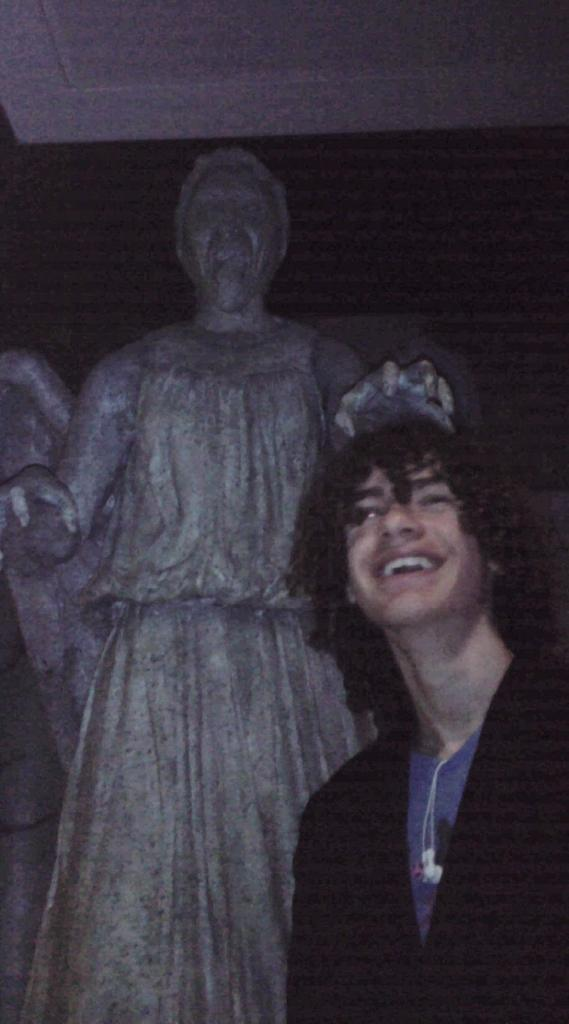Who or what is present in the image? There is a person in the image. Can you describe the person's attire? The person is wearing a dress with white, black, and purple colors. What can be seen in the background of the image? There is a statue of a person in the background. How would you describe the color scheme of the background? The background has a black and ash color. How many rings are visible on the person's fingers in the image? There is no mention of rings in the provided facts, so we cannot determine if any rings are visible on the person's fingers in the image. 